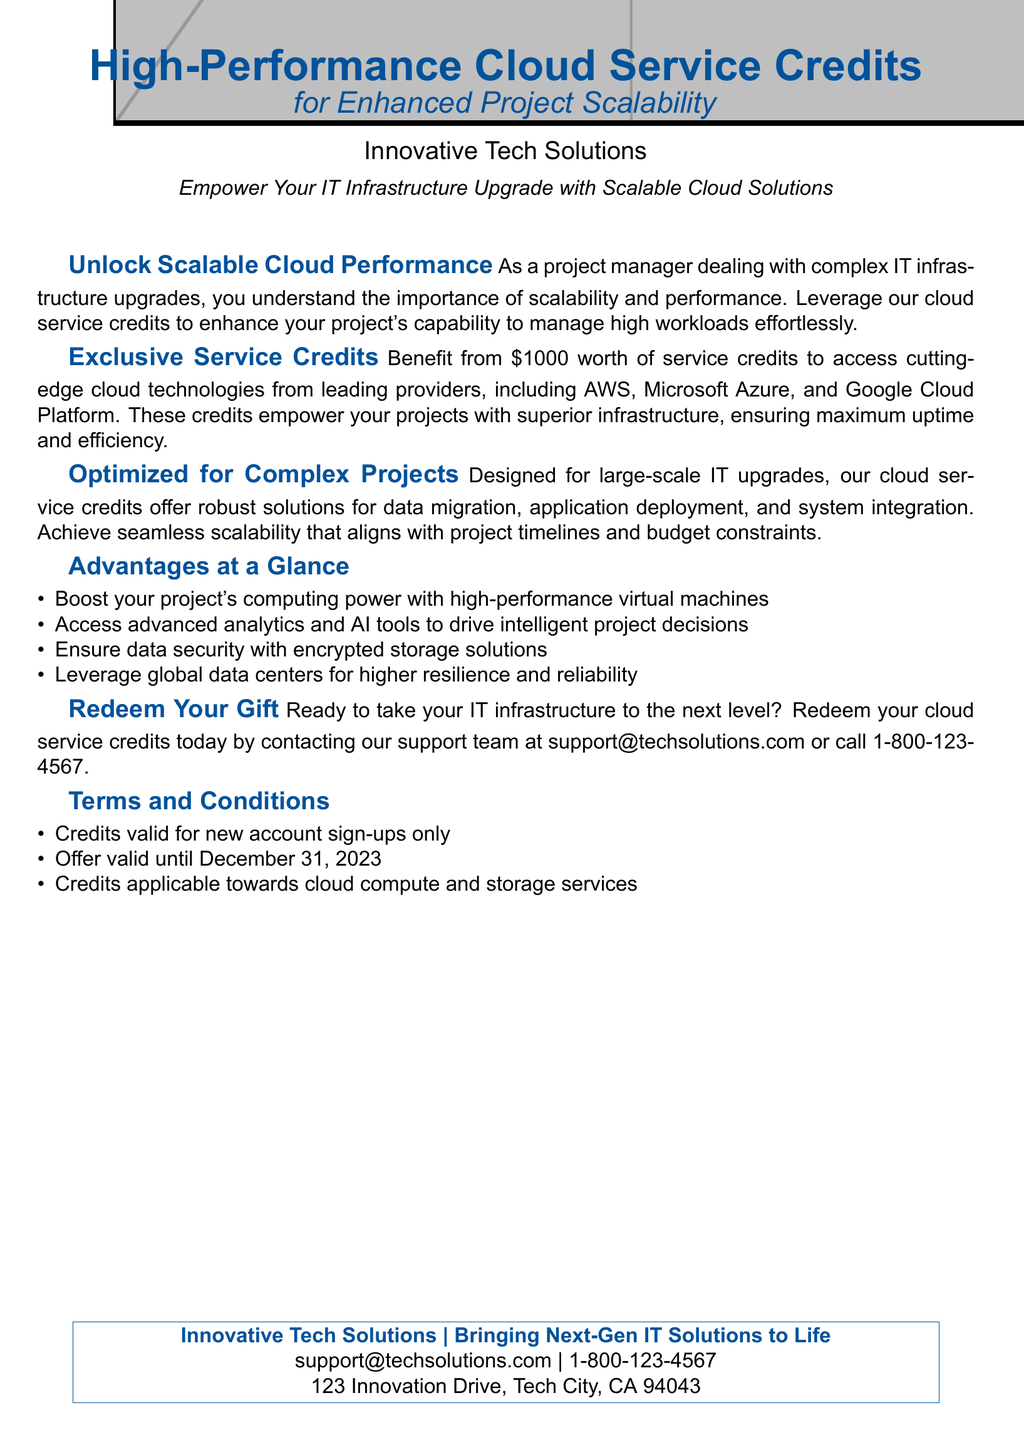What is the value of the service credits? The value of the service credits is specified in the document as \$1000.
Answer: \$1000 Which companies' cloud technologies are mentioned? The document lists several providers, including AWS, Microsoft Azure, and Google Cloud Platform.
Answer: AWS, Microsoft Azure, and Google Cloud Platform What is the primary purpose of the service credits? The document states that the credits are intended to enhance project scalability for IT infrastructure upgrades.
Answer: Enhance project scalability When do the credits expire? The expiration date for the credits is given in the document as December 31, 2023.
Answer: December 31, 2023 What is the contact email for support? The support contact email is provided in the document.
Answer: support@techsolutions.com How many advantages of the service credits are listed? The document lists four advantages of the service credits.
Answer: Four Which feature ensures data security? The document mentions encrypted storage solutions as a feature that ensures data security.
Answer: Encrypted storage solutions What type of projects are optimized for the cloud service credits? The cloud service credits are optimized for large-scale IT upgrades according to the document.
Answer: Large-scale IT upgrades 